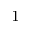Convert formula to latex. <formula><loc_0><loc_0><loc_500><loc_500>^ { - 1 }</formula> 